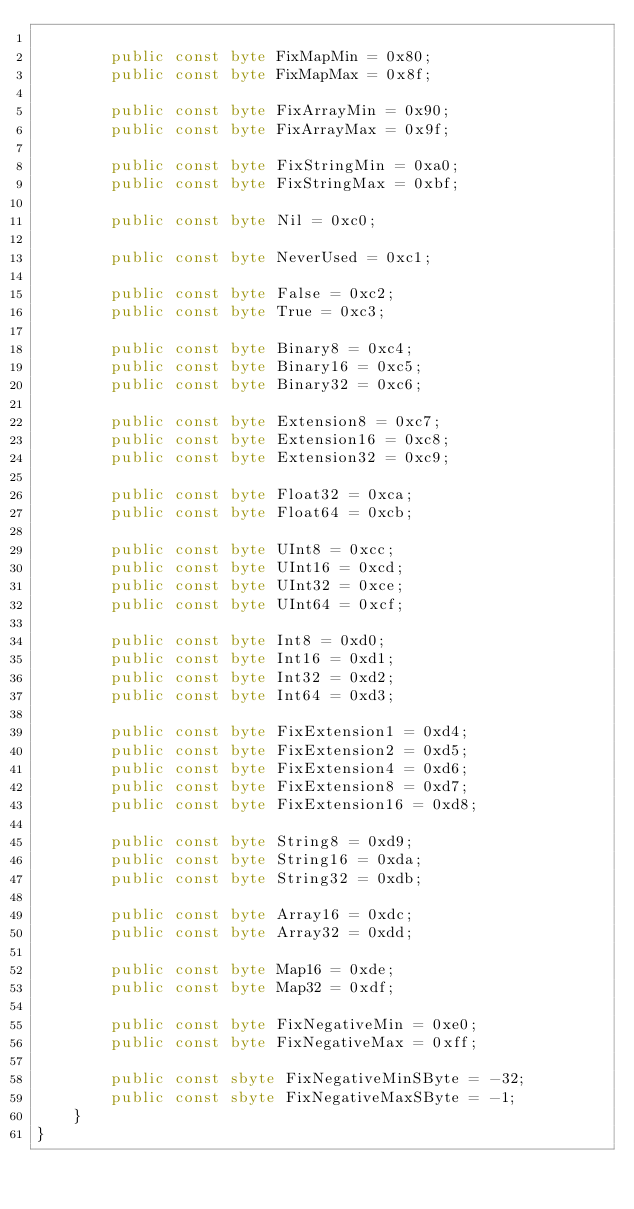<code> <loc_0><loc_0><loc_500><loc_500><_C#_>
        public const byte FixMapMin = 0x80;
        public const byte FixMapMax = 0x8f;

        public const byte FixArrayMin = 0x90;
        public const byte FixArrayMax = 0x9f;

        public const byte FixStringMin = 0xa0;
        public const byte FixStringMax = 0xbf;

        public const byte Nil = 0xc0;

        public const byte NeverUsed = 0xc1;

        public const byte False = 0xc2;
        public const byte True = 0xc3;

        public const byte Binary8 = 0xc4;
        public const byte Binary16 = 0xc5;
        public const byte Binary32 = 0xc6;

        public const byte Extension8 = 0xc7;
        public const byte Extension16 = 0xc8;
        public const byte Extension32 = 0xc9;

        public const byte Float32 = 0xca;
        public const byte Float64 = 0xcb;

        public const byte UInt8 = 0xcc;
        public const byte UInt16 = 0xcd;
        public const byte UInt32 = 0xce;
        public const byte UInt64 = 0xcf;

        public const byte Int8 = 0xd0;
        public const byte Int16 = 0xd1;
        public const byte Int32 = 0xd2;
        public const byte Int64 = 0xd3;

        public const byte FixExtension1 = 0xd4;
        public const byte FixExtension2 = 0xd5;
        public const byte FixExtension4 = 0xd6;
        public const byte FixExtension8 = 0xd7;
        public const byte FixExtension16 = 0xd8;

        public const byte String8 = 0xd9;
        public const byte String16 = 0xda;
        public const byte String32 = 0xdb;

        public const byte Array16 = 0xdc;
        public const byte Array32 = 0xdd;

        public const byte Map16 = 0xde;
        public const byte Map32 = 0xdf;

        public const byte FixNegativeMin = 0xe0;
        public const byte FixNegativeMax = 0xff;

        public const sbyte FixNegativeMinSByte = -32;
        public const sbyte FixNegativeMaxSByte = -1;
    }
}
</code> 